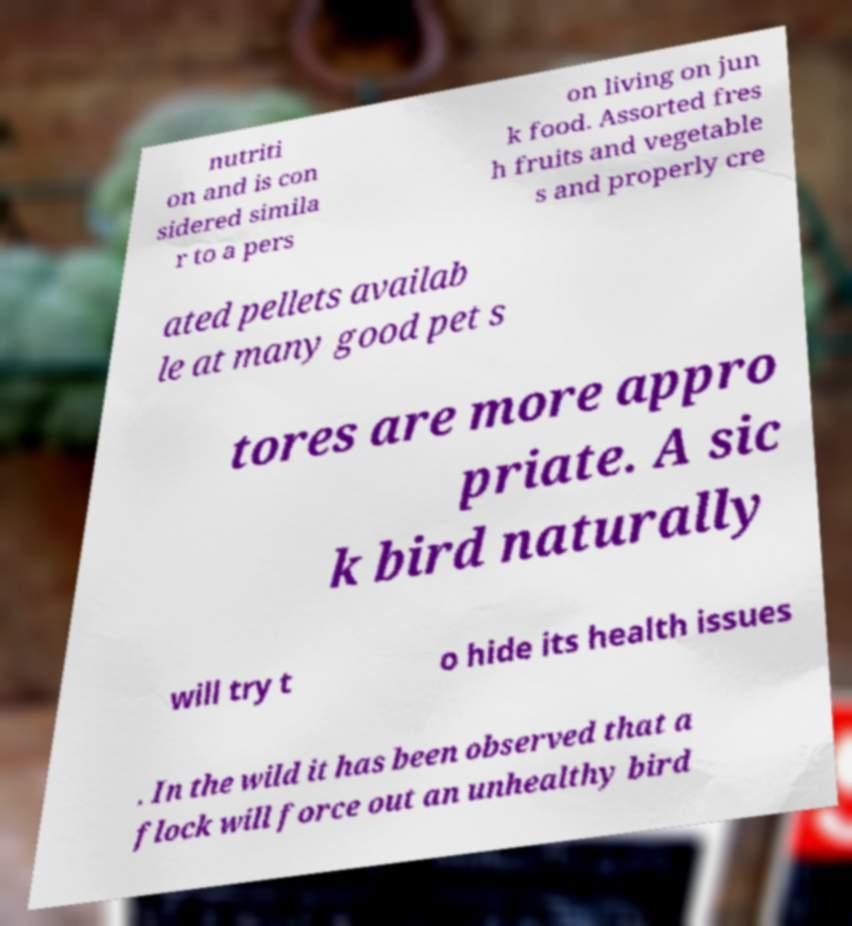I need the written content from this picture converted into text. Can you do that? nutriti on and is con sidered simila r to a pers on living on jun k food. Assorted fres h fruits and vegetable s and properly cre ated pellets availab le at many good pet s tores are more appro priate. A sic k bird naturally will try t o hide its health issues . In the wild it has been observed that a flock will force out an unhealthy bird 